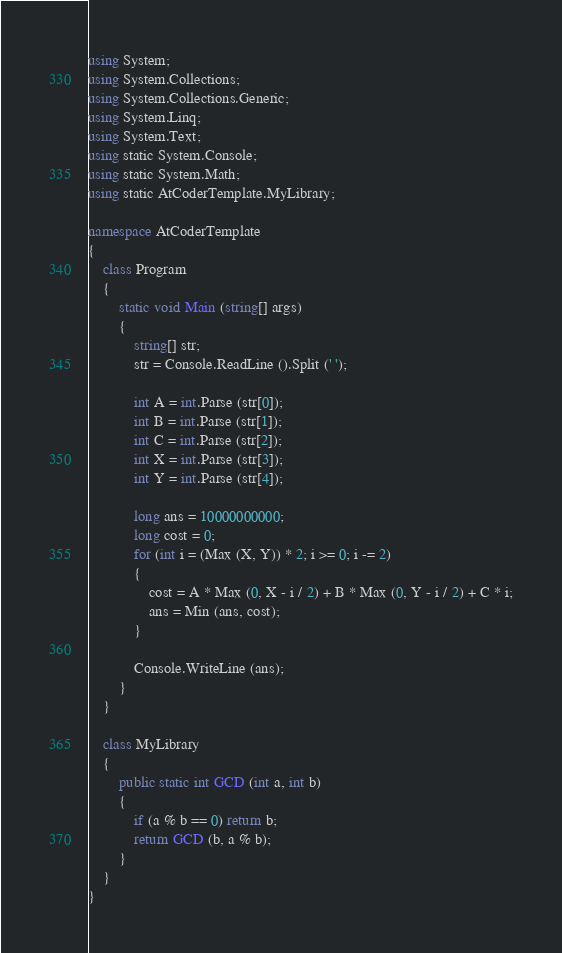Convert code to text. <code><loc_0><loc_0><loc_500><loc_500><_C#_>using System;
using System.Collections;
using System.Collections.Generic;
using System.Linq;
using System.Text;
using static System.Console;
using static System.Math;
using static AtCoderTemplate.MyLibrary;

namespace AtCoderTemplate
{
    class Program
    {
        static void Main (string[] args)
        {
            string[] str;
            str = Console.ReadLine ().Split (' ');

            int A = int.Parse (str[0]);
            int B = int.Parse (str[1]);
            int C = int.Parse (str[2]);
            int X = int.Parse (str[3]);
            int Y = int.Parse (str[4]);

            long ans = 10000000000;
            long cost = 0;
            for (int i = (Max (X, Y)) * 2; i >= 0; i -= 2)
            {
                cost = A * Max (0, X - i / 2) + B * Max (0, Y - i / 2) + C * i;
                ans = Min (ans, cost);
            }

            Console.WriteLine (ans);
        }
    }

    class MyLibrary
    {
        public static int GCD (int a, int b)
        {
            if (a % b == 0) return b;
            return GCD (b, a % b);
        }
    }
}</code> 